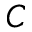Convert formula to latex. <formula><loc_0><loc_0><loc_500><loc_500>C</formula> 